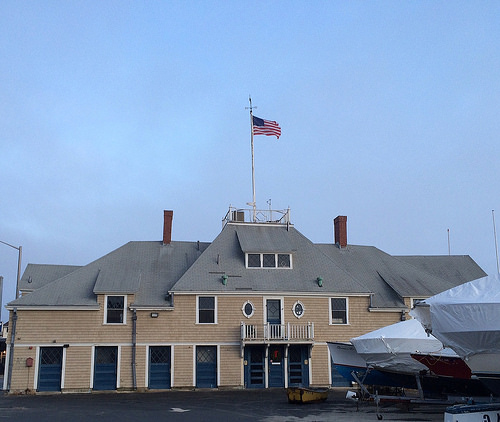<image>
Can you confirm if the flag is in front of the house? No. The flag is not in front of the house. The spatial positioning shows a different relationship between these objects. 